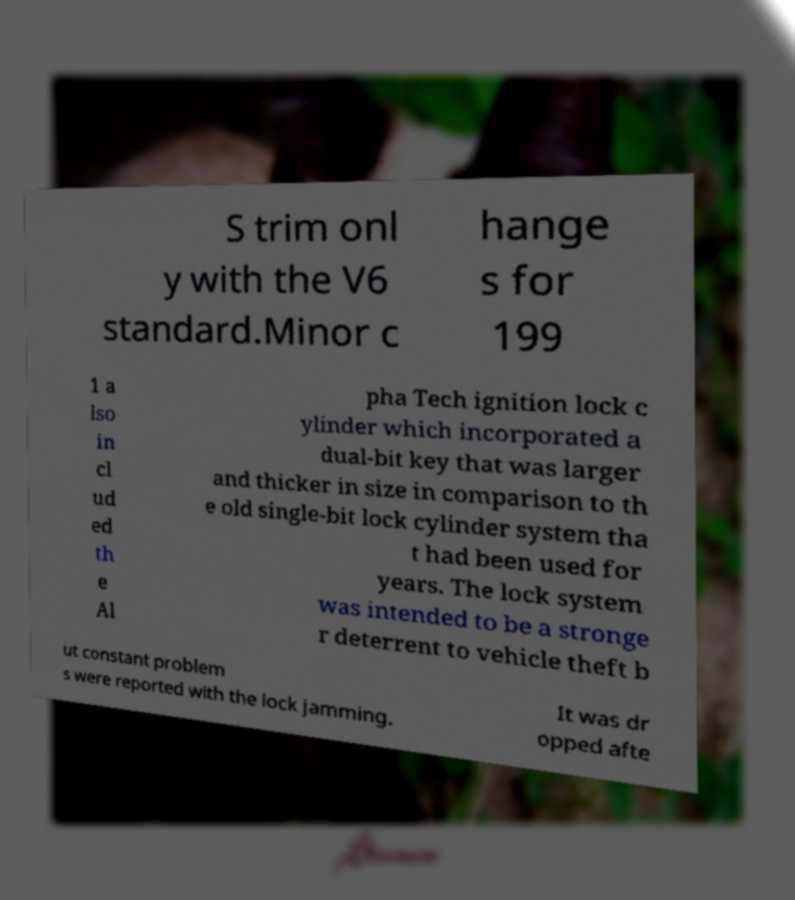For documentation purposes, I need the text within this image transcribed. Could you provide that? S trim onl y with the V6 standard.Minor c hange s for 199 1 a lso in cl ud ed th e Al pha Tech ignition lock c ylinder which incorporated a dual-bit key that was larger and thicker in size in comparison to th e old single-bit lock cylinder system tha t had been used for years. The lock system was intended to be a stronge r deterrent to vehicle theft b ut constant problem s were reported with the lock jamming. It was dr opped afte 